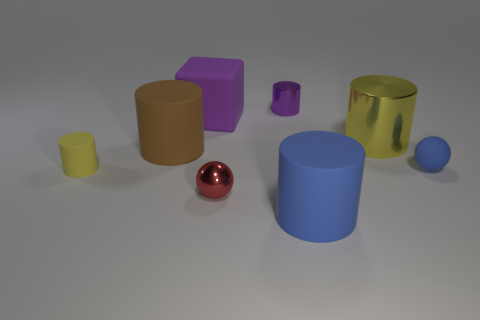Subtract all big blue rubber cylinders. How many cylinders are left? 4 Subtract all brown cylinders. How many cylinders are left? 4 Subtract 2 cylinders. How many cylinders are left? 3 Subtract all green cylinders. Subtract all gray blocks. How many cylinders are left? 5 Add 2 red shiny objects. How many objects exist? 10 Subtract all blocks. How many objects are left? 7 Add 3 tiny shiny spheres. How many tiny shiny spheres exist? 4 Subtract 0 gray blocks. How many objects are left? 8 Subtract all green rubber objects. Subtract all big purple matte objects. How many objects are left? 7 Add 2 big purple rubber objects. How many big purple rubber objects are left? 3 